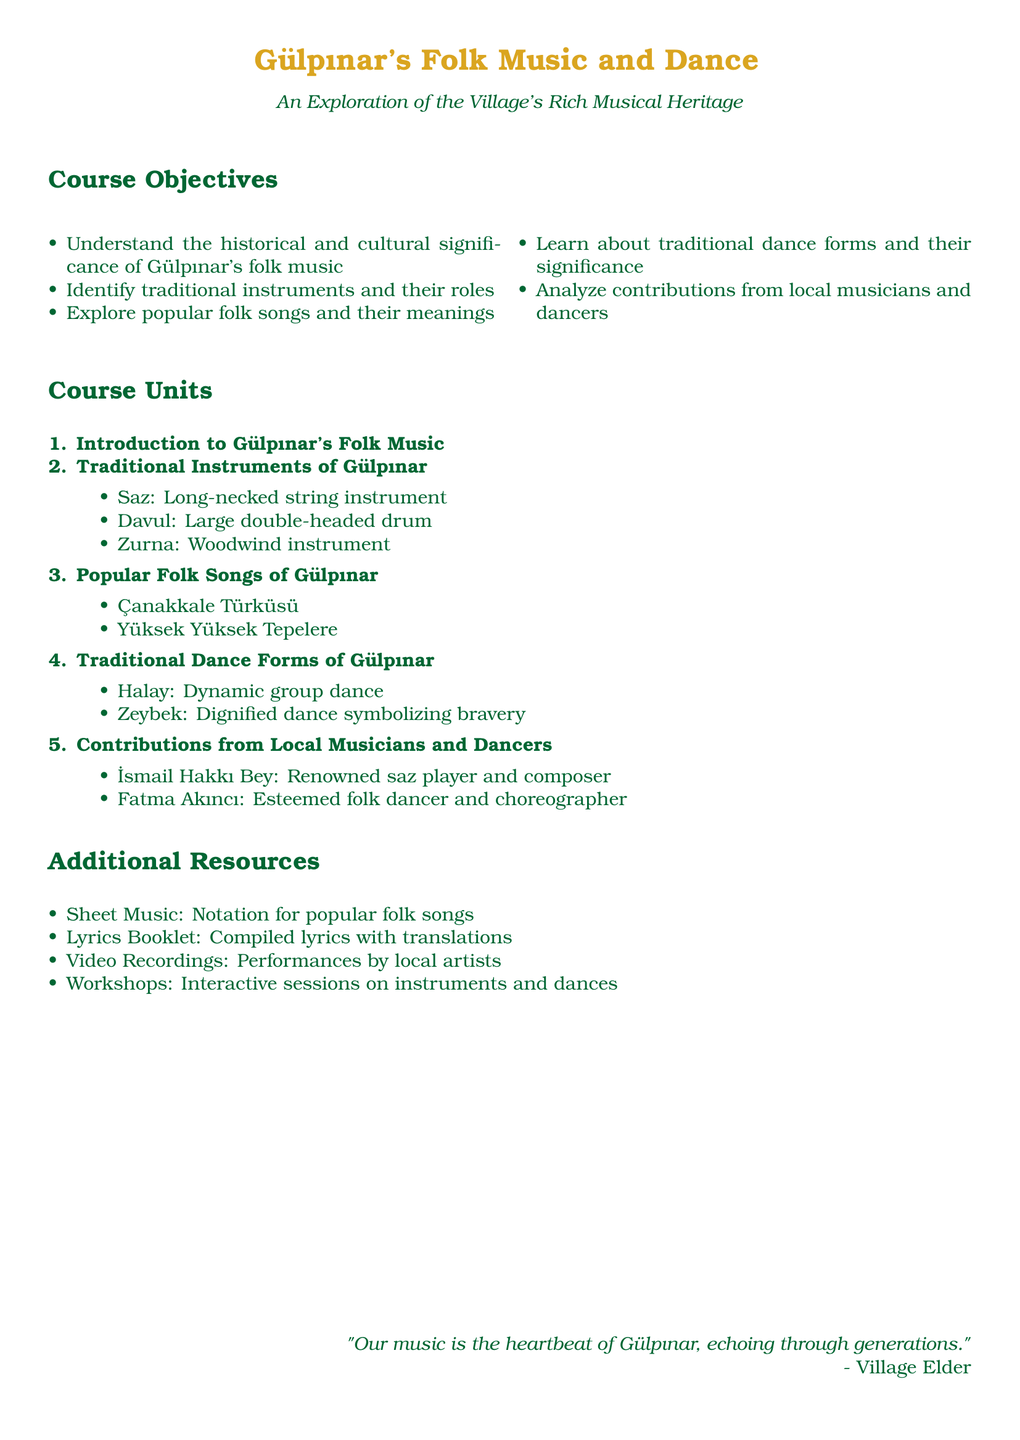what is the title of the syllabus? The title is found at the beginning of the document, which clearly states the focus of the course.
Answer: Gülpınar's Folk Music and Dance how many traditional instruments are listed? The document enumerates the traditional instruments in a dedicated section.
Answer: 3 name one popular folk song from Gülpınar. The popular folk songs are detailed in a specific section of the syllabus.
Answer: Çanakkale Türküsü what is the first course unit? The first course unit is mentioned in the enumeration of units in the document.
Answer: Introduction to Gülpınar's Folk Music who is a renowned saz player mentioned? The contributions from local musicians are outlined in a specific section, naming key individuals.
Answer: İsmail Hakkı Bey what is the significance of the Zeybek dance? The description of the Zeybek dance highlights its cultural symbols.
Answer: Dignified dance symbolizing bravery how many contributions from local musicians and dancers are mentioned? The document specifies the contributions in a section dedicated to local talent.
Answer: 2 name one resource mentioned in the additional resources. The additional resources provide various supportive materials related to the course.
Answer: Sheet Music 